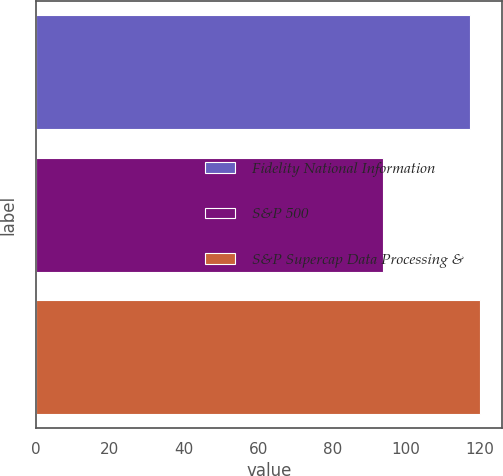Convert chart. <chart><loc_0><loc_0><loc_500><loc_500><bar_chart><fcel>Fidelity National Information<fcel>S&P 500<fcel>S&P Supercap Data Processing &<nl><fcel>117.34<fcel>93.61<fcel>119.85<nl></chart> 